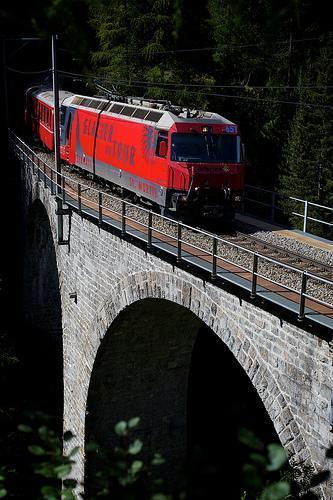How many trains are there?
Give a very brief answer. 1. 